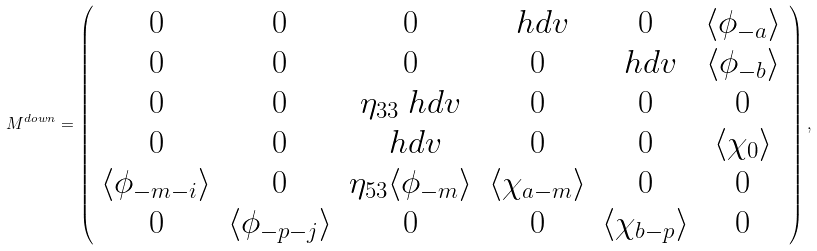Convert formula to latex. <formula><loc_0><loc_0><loc_500><loc_500>M ^ { d o w n } = \left ( \begin{array} { * { 6 } { c } } 0 & 0 & 0 & \ h d v & 0 & \langle \phi _ { - a } \rangle \\ 0 & 0 & 0 & 0 & \ h d v & \langle \phi _ { - b } \rangle \\ 0 & 0 & \eta _ { 3 3 } \ h d v & 0 & 0 & 0 \\ 0 & 0 & \ h d v & 0 & 0 & \langle \chi _ { 0 } \rangle \\ \langle \phi _ { - m - i } \rangle & 0 & \eta _ { 5 3 } \langle \phi _ { - m } \rangle & \langle \chi _ { a - m } \rangle & 0 & 0 \\ 0 & \langle \phi _ { - p - j } \rangle & 0 & 0 & \langle \chi _ { b - p } \rangle & 0 \\ \end{array} \right ) ,</formula> 